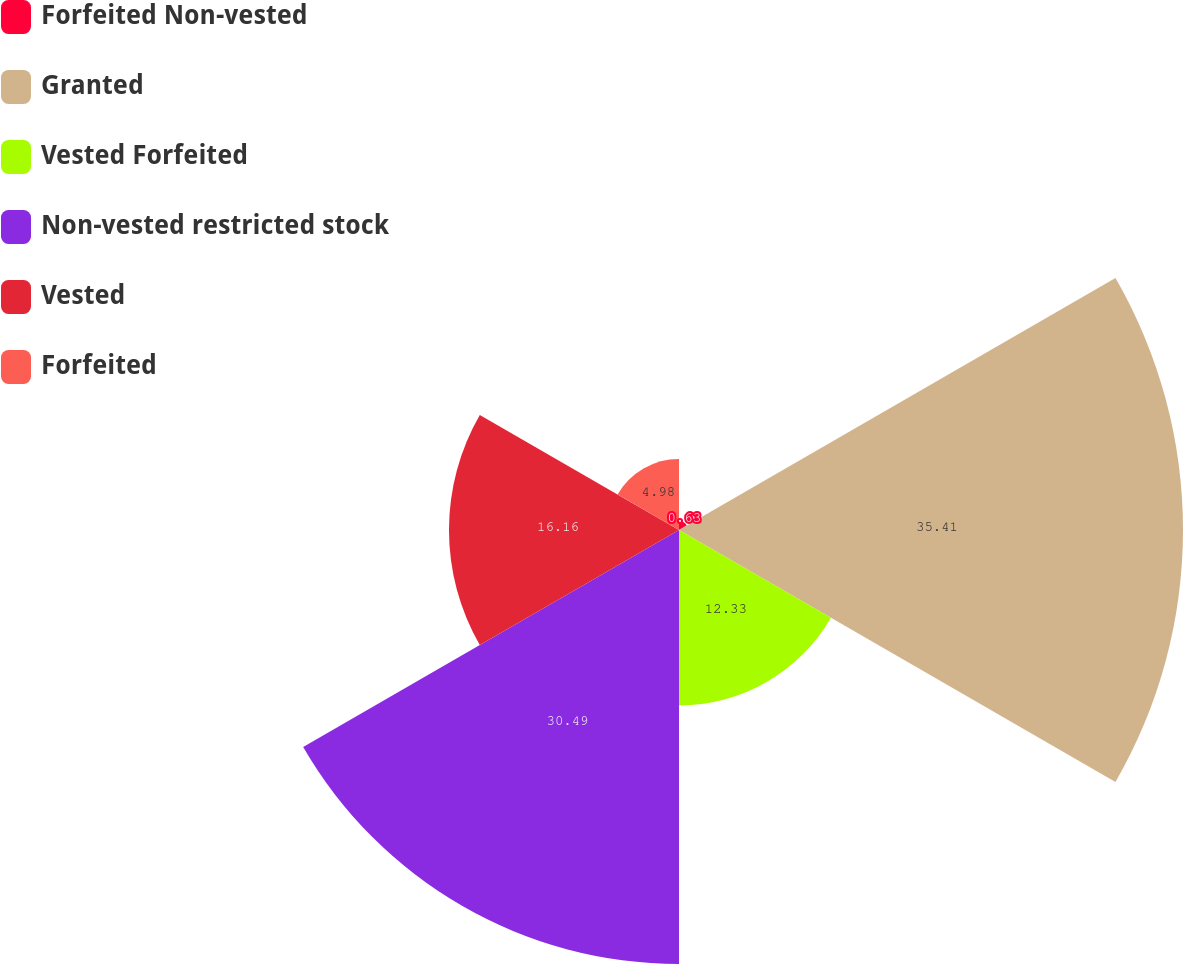Convert chart to OTSL. <chart><loc_0><loc_0><loc_500><loc_500><pie_chart><fcel>Forfeited Non-vested<fcel>Granted<fcel>Vested Forfeited<fcel>Non-vested restricted stock<fcel>Vested<fcel>Forfeited<nl><fcel>0.63%<fcel>35.41%<fcel>12.33%<fcel>30.49%<fcel>16.16%<fcel>4.98%<nl></chart> 